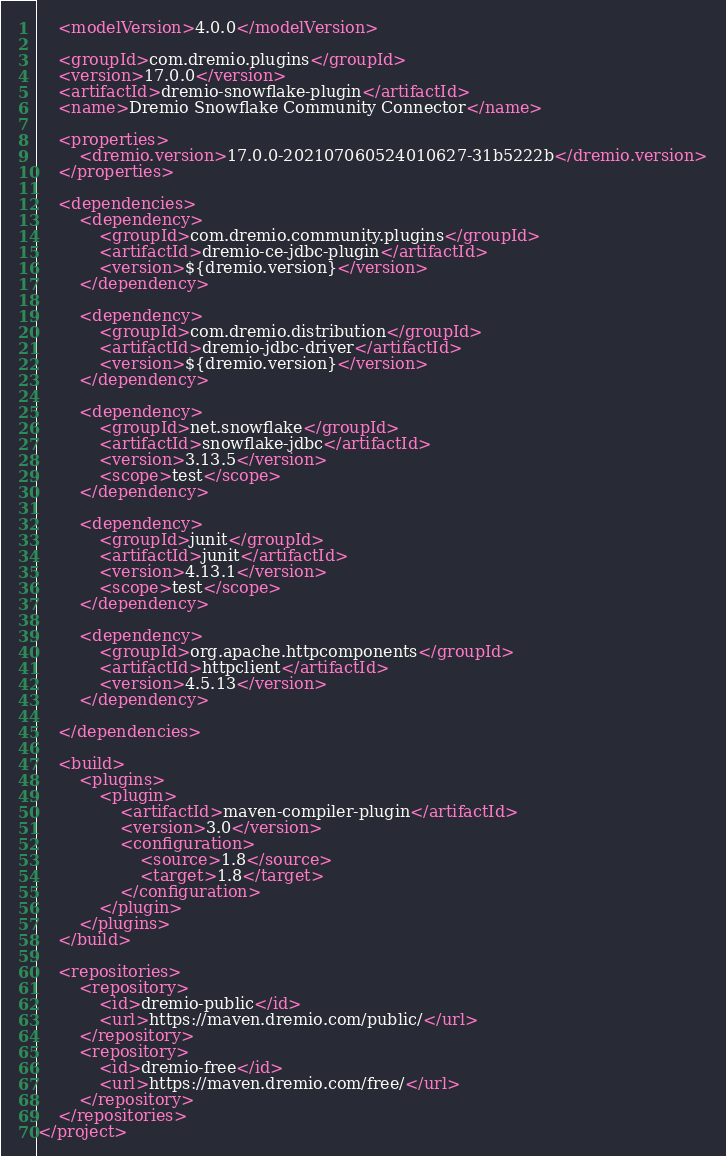<code> <loc_0><loc_0><loc_500><loc_500><_XML_>    <modelVersion>4.0.0</modelVersion>

    <groupId>com.dremio.plugins</groupId>
    <version>17.0.0</version>
    <artifactId>dremio-snowflake-plugin</artifactId>
    <name>Dremio Snowflake Community Connector</name>

    <properties>
        <dremio.version>17.0.0-202107060524010627-31b5222b</dremio.version>
    </properties>

    <dependencies>
        <dependency>
            <groupId>com.dremio.community.plugins</groupId>
            <artifactId>dremio-ce-jdbc-plugin</artifactId>
            <version>${dremio.version}</version>
        </dependency>

        <dependency>
            <groupId>com.dremio.distribution</groupId>
            <artifactId>dremio-jdbc-driver</artifactId>
            <version>${dremio.version}</version>
        </dependency>

        <dependency>
            <groupId>net.snowflake</groupId>
            <artifactId>snowflake-jdbc</artifactId>
            <version>3.13.5</version>
            <scope>test</scope>
        </dependency>

        <dependency>
            <groupId>junit</groupId>
            <artifactId>junit</artifactId>
            <version>4.13.1</version>
            <scope>test</scope>
        </dependency>

        <dependency>
            <groupId>org.apache.httpcomponents</groupId>
            <artifactId>httpclient</artifactId>
            <version>4.5.13</version>
        </dependency>

    </dependencies>

    <build>
        <plugins>
            <plugin>
                <artifactId>maven-compiler-plugin</artifactId>
                <version>3.0</version>
                <configuration>
                    <source>1.8</source>
                    <target>1.8</target>
                </configuration>
            </plugin>
        </plugins>
    </build>

    <repositories>
        <repository>
            <id>dremio-public</id>
            <url>https://maven.dremio.com/public/</url>
        </repository>
        <repository>
            <id>dremio-free</id>
            <url>https://maven.dremio.com/free/</url>
        </repository>
    </repositories>
</project>

</code> 